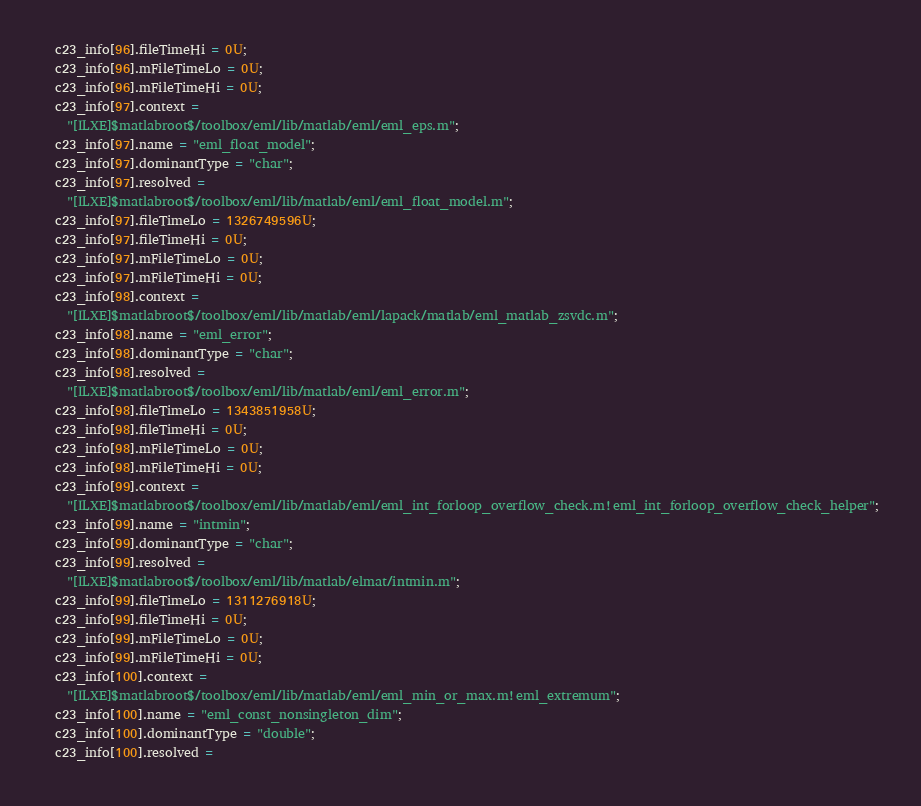<code> <loc_0><loc_0><loc_500><loc_500><_C_>  c23_info[96].fileTimeHi = 0U;
  c23_info[96].mFileTimeLo = 0U;
  c23_info[96].mFileTimeHi = 0U;
  c23_info[97].context =
    "[ILXE]$matlabroot$/toolbox/eml/lib/matlab/eml/eml_eps.m";
  c23_info[97].name = "eml_float_model";
  c23_info[97].dominantType = "char";
  c23_info[97].resolved =
    "[ILXE]$matlabroot$/toolbox/eml/lib/matlab/eml/eml_float_model.m";
  c23_info[97].fileTimeLo = 1326749596U;
  c23_info[97].fileTimeHi = 0U;
  c23_info[97].mFileTimeLo = 0U;
  c23_info[97].mFileTimeHi = 0U;
  c23_info[98].context =
    "[ILXE]$matlabroot$/toolbox/eml/lib/matlab/eml/lapack/matlab/eml_matlab_zsvdc.m";
  c23_info[98].name = "eml_error";
  c23_info[98].dominantType = "char";
  c23_info[98].resolved =
    "[ILXE]$matlabroot$/toolbox/eml/lib/matlab/eml/eml_error.m";
  c23_info[98].fileTimeLo = 1343851958U;
  c23_info[98].fileTimeHi = 0U;
  c23_info[98].mFileTimeLo = 0U;
  c23_info[98].mFileTimeHi = 0U;
  c23_info[99].context =
    "[ILXE]$matlabroot$/toolbox/eml/lib/matlab/eml/eml_int_forloop_overflow_check.m!eml_int_forloop_overflow_check_helper";
  c23_info[99].name = "intmin";
  c23_info[99].dominantType = "char";
  c23_info[99].resolved =
    "[ILXE]$matlabroot$/toolbox/eml/lib/matlab/elmat/intmin.m";
  c23_info[99].fileTimeLo = 1311276918U;
  c23_info[99].fileTimeHi = 0U;
  c23_info[99].mFileTimeLo = 0U;
  c23_info[99].mFileTimeHi = 0U;
  c23_info[100].context =
    "[ILXE]$matlabroot$/toolbox/eml/lib/matlab/eml/eml_min_or_max.m!eml_extremum";
  c23_info[100].name = "eml_const_nonsingleton_dim";
  c23_info[100].dominantType = "double";
  c23_info[100].resolved =</code> 